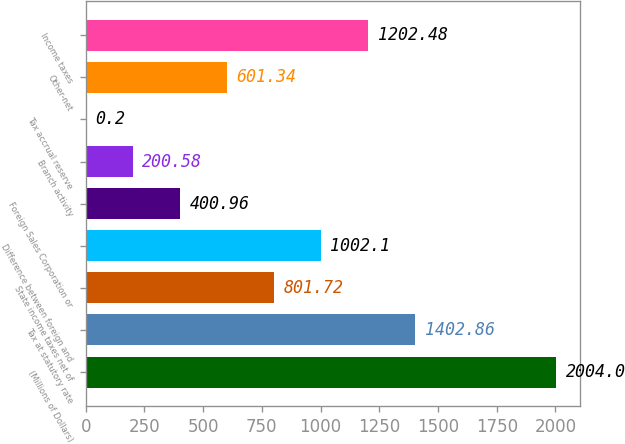Convert chart. <chart><loc_0><loc_0><loc_500><loc_500><bar_chart><fcel>(Millions of Dollars)<fcel>Tax at statutory rate<fcel>State income taxes net of<fcel>Difference between foreign and<fcel>Foreign Sales Corporation or<fcel>Branch activity<fcel>Tax accrual reserve<fcel>Other-net<fcel>Income taxes<nl><fcel>2004<fcel>1402.86<fcel>801.72<fcel>1002.1<fcel>400.96<fcel>200.58<fcel>0.2<fcel>601.34<fcel>1202.48<nl></chart> 